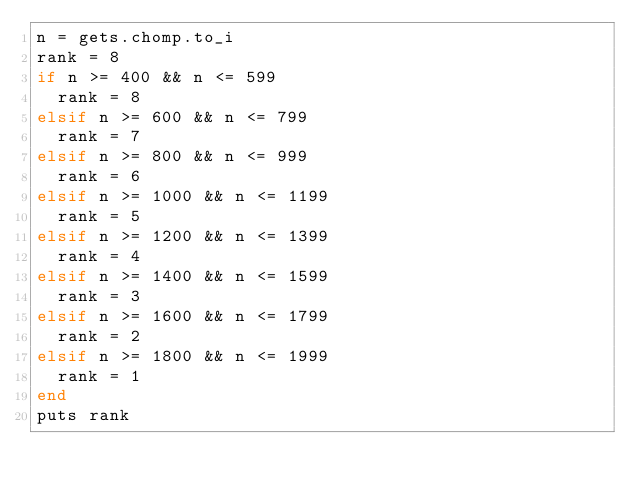<code> <loc_0><loc_0><loc_500><loc_500><_Ruby_>n = gets.chomp.to_i
rank = 8
if n >= 400 && n <= 599
  rank = 8
elsif n >= 600 && n <= 799
  rank = 7
elsif n >= 800 && n <= 999
  rank = 6
elsif n >= 1000 && n <= 1199
  rank = 5
elsif n >= 1200 && n <= 1399
  rank = 4
elsif n >= 1400 && n <= 1599
  rank = 3
elsif n >= 1600 && n <= 1799
  rank = 2
elsif n >= 1800 && n <= 1999
  rank = 1
end
puts rank</code> 